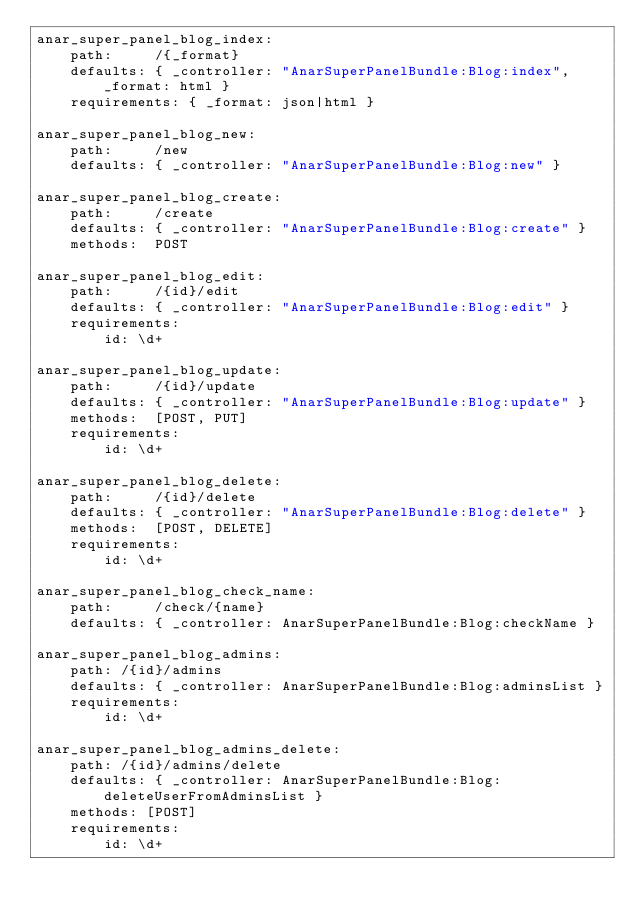Convert code to text. <code><loc_0><loc_0><loc_500><loc_500><_YAML_>anar_super_panel_blog_index:
    path:     /{_format}
    defaults: { _controller: "AnarSuperPanelBundle:Blog:index", _format: html }
    requirements: { _format: json|html }

anar_super_panel_blog_new:
    path:     /new
    defaults: { _controller: "AnarSuperPanelBundle:Blog:new" }

anar_super_panel_blog_create:
    path:     /create
    defaults: { _controller: "AnarSuperPanelBundle:Blog:create" }
    methods:  POST

anar_super_panel_blog_edit:
    path:     /{id}/edit
    defaults: { _controller: "AnarSuperPanelBundle:Blog:edit" }
    requirements:
        id: \d+

anar_super_panel_blog_update:
    path:     /{id}/update
    defaults: { _controller: "AnarSuperPanelBundle:Blog:update" }
    methods:  [POST, PUT]
    requirements:
        id: \d+

anar_super_panel_blog_delete:
    path:     /{id}/delete
    defaults: { _controller: "AnarSuperPanelBundle:Blog:delete" }
    methods:  [POST, DELETE]
    requirements:
        id: \d+

anar_super_panel_blog_check_name:
    path:     /check/{name}
    defaults: { _controller: AnarSuperPanelBundle:Blog:checkName }

anar_super_panel_blog_admins:
    path: /{id}/admins
    defaults: { _controller: AnarSuperPanelBundle:Blog:adminsList }
    requirements:
        id: \d+

anar_super_panel_blog_admins_delete:
    path: /{id}/admins/delete
    defaults: { _controller: AnarSuperPanelBundle:Blog:deleteUserFromAdminsList }
    methods: [POST]
    requirements:
        id: \d+</code> 